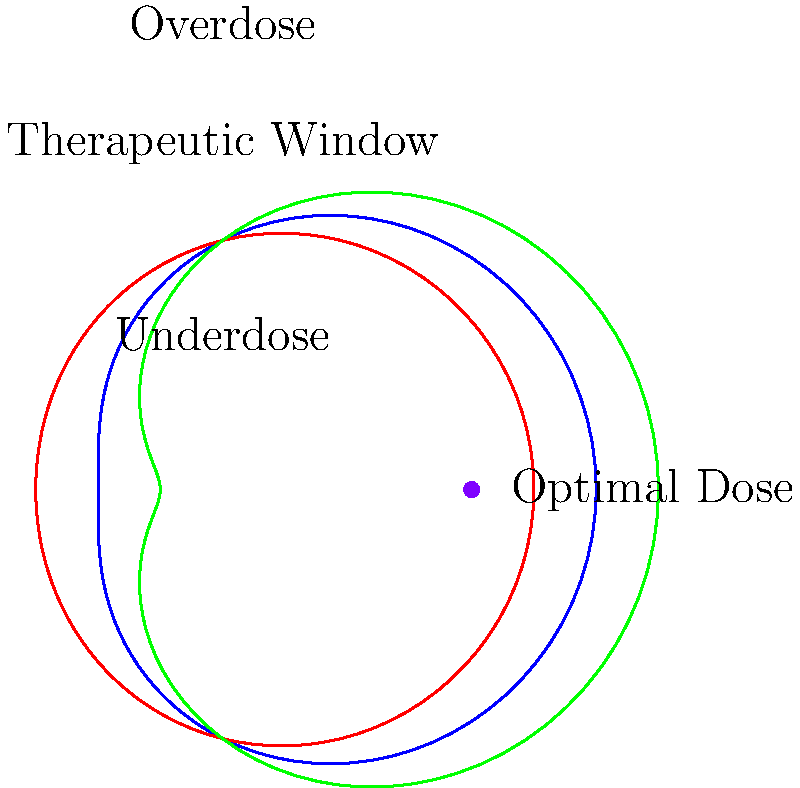In the polar coordinate graph representing the relationship between drug dosage and therapeutic effect, which color represents the optimal dosage curve that maximizes therapeutic benefit while minimizing risks of under or overdosing? To answer this question, let's analyze the graph step-by-step:

1. The graph shows three concentric curves in different colors: blue, red, and green.

2. These curves represent different dosage levels and their corresponding therapeutic effects.

3. The graph is divided into three regions:
   - "Underdose" at the center
   - "Therapeutic Window" in the middle
   - "Overdose" at the outer edge

4. The ideal dosage curve should:
   a) Maximize time spent in the "Therapeutic Window"
   b) Minimize time spent in "Underdose" and "Overdose" regions

5. Examining each curve:
   - The red curve (innermost) spends most time in the "Underdose" region
   - The green curve (outermost) frequently enters the "Overdose" region
   - The blue curve (middle) stays primarily within the "Therapeutic Window"

6. There's a purple dot labeled "Optimal Dose" on the right side of the graph, aligned with the blue curve.

7. The blue curve best represents the balance between effective treatment and safety, as it maximizes time in the "Therapeutic Window" while minimizing risks of under or overdosing.

Therefore, the blue curve represents the optimal dosage curve.
Answer: Blue 